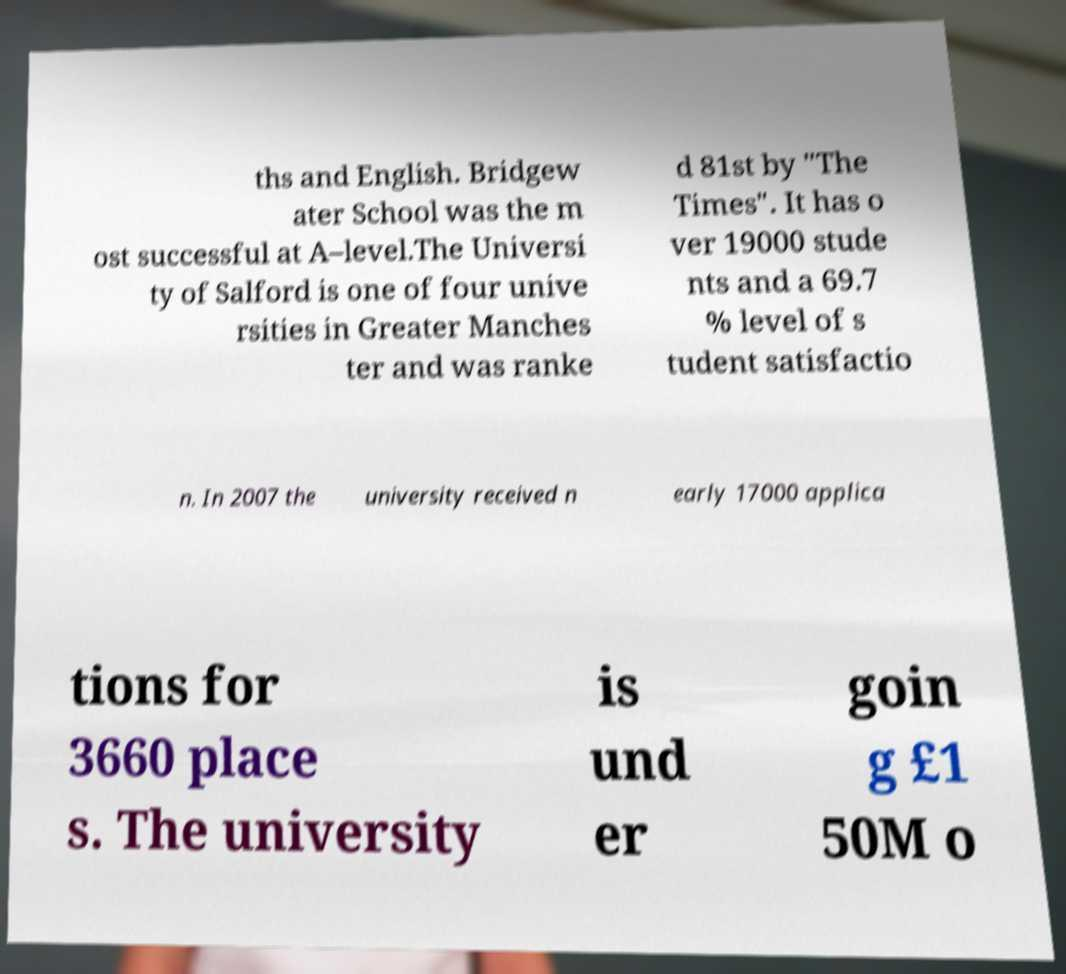Could you extract and type out the text from this image? ths and English. Bridgew ater School was the m ost successful at A–level.The Universi ty of Salford is one of four unive rsities in Greater Manches ter and was ranke d 81st by "The Times". It has o ver 19000 stude nts and a 69.7 % level of s tudent satisfactio n. In 2007 the university received n early 17000 applica tions for 3660 place s. The university is und er goin g £1 50M o 